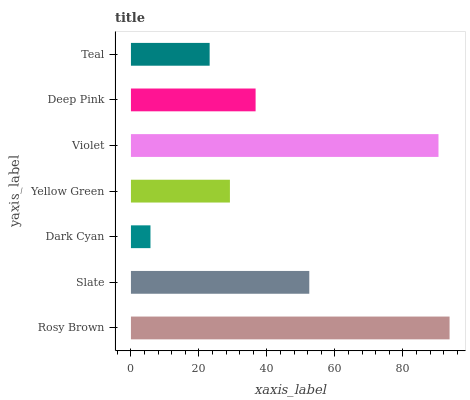Is Dark Cyan the minimum?
Answer yes or no. Yes. Is Rosy Brown the maximum?
Answer yes or no. Yes. Is Slate the minimum?
Answer yes or no. No. Is Slate the maximum?
Answer yes or no. No. Is Rosy Brown greater than Slate?
Answer yes or no. Yes. Is Slate less than Rosy Brown?
Answer yes or no. Yes. Is Slate greater than Rosy Brown?
Answer yes or no. No. Is Rosy Brown less than Slate?
Answer yes or no. No. Is Deep Pink the high median?
Answer yes or no. Yes. Is Deep Pink the low median?
Answer yes or no. Yes. Is Violet the high median?
Answer yes or no. No. Is Yellow Green the low median?
Answer yes or no. No. 